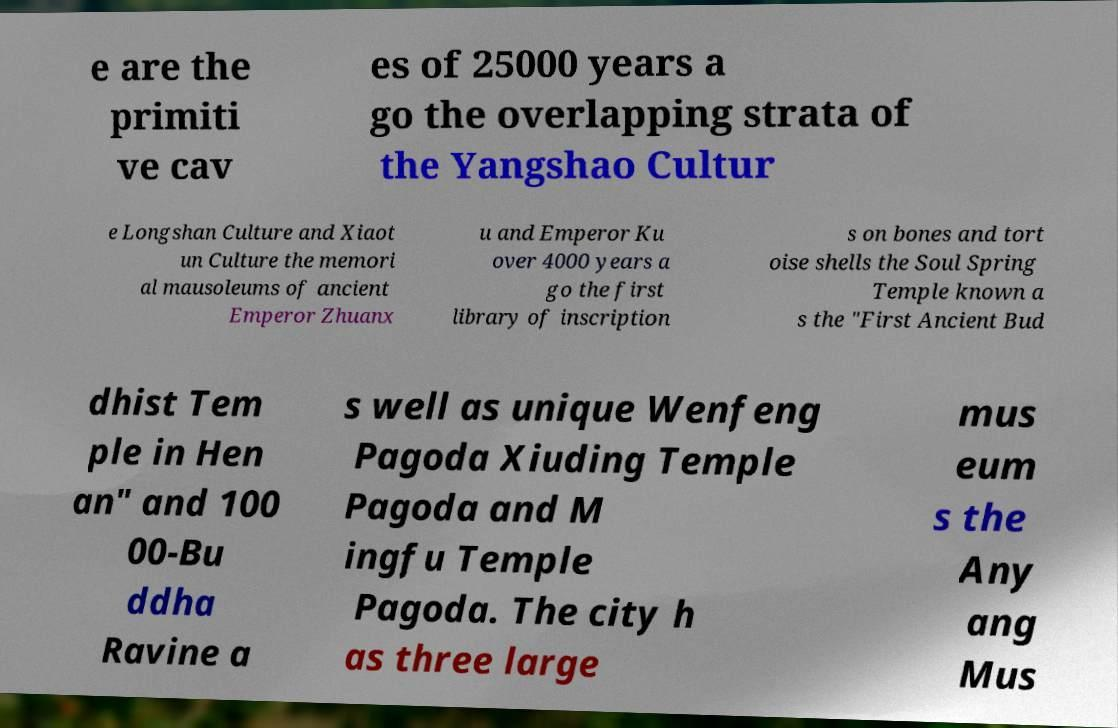Can you read and provide the text displayed in the image?This photo seems to have some interesting text. Can you extract and type it out for me? e are the primiti ve cav es of 25000 years a go the overlapping strata of the Yangshao Cultur e Longshan Culture and Xiaot un Culture the memori al mausoleums of ancient Emperor Zhuanx u and Emperor Ku over 4000 years a go the first library of inscription s on bones and tort oise shells the Soul Spring Temple known a s the "First Ancient Bud dhist Tem ple in Hen an" and 100 00-Bu ddha Ravine a s well as unique Wenfeng Pagoda Xiuding Temple Pagoda and M ingfu Temple Pagoda. The city h as three large mus eum s the Any ang Mus 